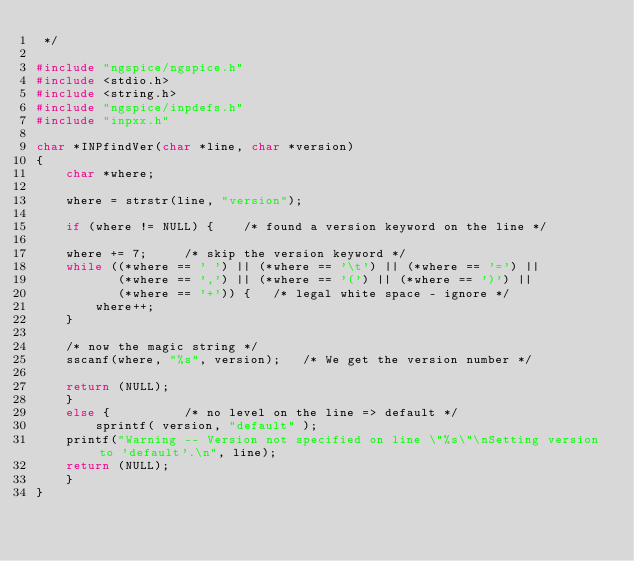<code> <loc_0><loc_0><loc_500><loc_500><_C_> */

#include "ngspice/ngspice.h"
#include <stdio.h>
#include <string.h>
#include "ngspice/inpdefs.h"
#include "inpxx.h"

char *INPfindVer(char *line, char *version)
{
    char *where;

    where = strstr(line, "version");

    if (where != NULL) {	/* found a version keyword on the line */

	where += 7;		/* skip the version keyword */
	while ((*where == ' ') || (*where == '\t') || (*where == '=') ||
	       (*where == ',') || (*where == '(') || (*where == ')') ||
	       (*where == '+')) {	/* legal white space - ignore */
	    where++;
	}

	/* now the magic string */
	sscanf(where, "%s", version);	/* We get the version number */

	return (NULL);
    }
    else {			/* no level on the line => default */
        sprintf( version, "default" );
	printf("Warning -- Version not specified on line \"%s\"\nSetting version to 'default'.\n", line);
	return (NULL);
    }
}
</code> 